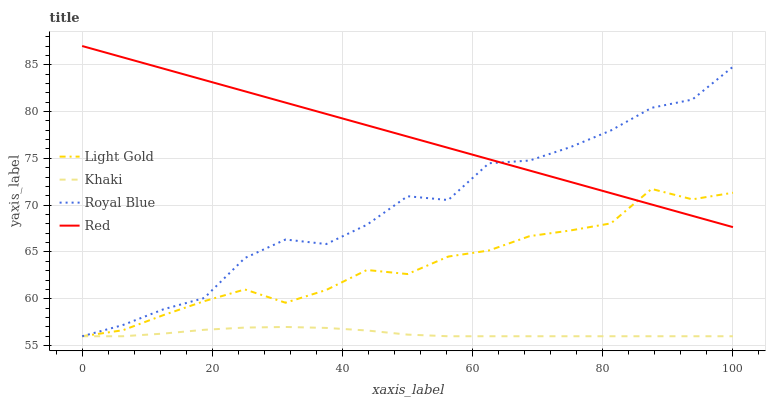Does Khaki have the minimum area under the curve?
Answer yes or no. Yes. Does Red have the maximum area under the curve?
Answer yes or no. Yes. Does Light Gold have the minimum area under the curve?
Answer yes or no. No. Does Light Gold have the maximum area under the curve?
Answer yes or no. No. Is Red the smoothest?
Answer yes or no. Yes. Is Royal Blue the roughest?
Answer yes or no. Yes. Is Khaki the smoothest?
Answer yes or no. No. Is Khaki the roughest?
Answer yes or no. No. Does Red have the lowest value?
Answer yes or no. No. Does Red have the highest value?
Answer yes or no. Yes. Does Light Gold have the highest value?
Answer yes or no. No. Is Khaki less than Red?
Answer yes or no. Yes. Is Red greater than Khaki?
Answer yes or no. Yes. Does Khaki intersect Light Gold?
Answer yes or no. Yes. Is Khaki less than Light Gold?
Answer yes or no. No. Is Khaki greater than Light Gold?
Answer yes or no. No. Does Khaki intersect Red?
Answer yes or no. No. 